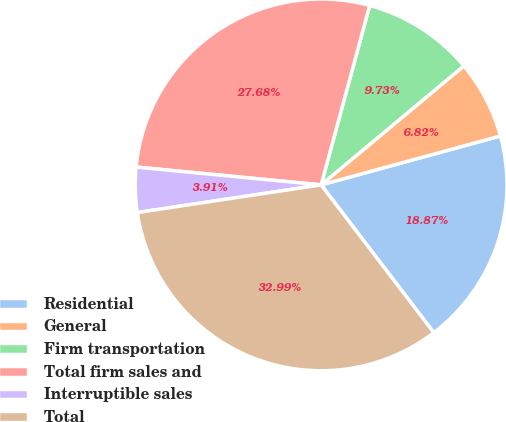<chart> <loc_0><loc_0><loc_500><loc_500><pie_chart><fcel>Residential<fcel>General<fcel>Firm transportation<fcel>Total firm sales and<fcel>Interruptible sales<fcel>Total<nl><fcel>18.87%<fcel>6.82%<fcel>9.73%<fcel>27.68%<fcel>3.91%<fcel>32.99%<nl></chart> 